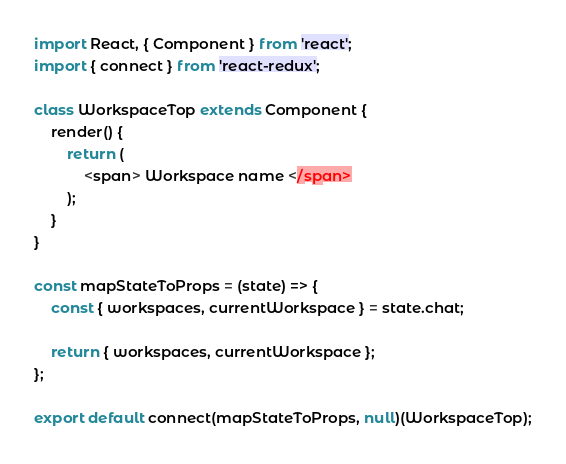<code> <loc_0><loc_0><loc_500><loc_500><_JavaScript_>import React, { Component } from 'react';
import { connect } from 'react-redux';

class WorkspaceTop extends Component {
    render() {
        return (
            <span> Workspace name </span>
        );
    }
}

const mapStateToProps = (state) => {
    const { workspaces, currentWorkspace } = state.chat;

    return { workspaces, currentWorkspace };
};

export default connect(mapStateToProps, null)(WorkspaceTop);</code> 